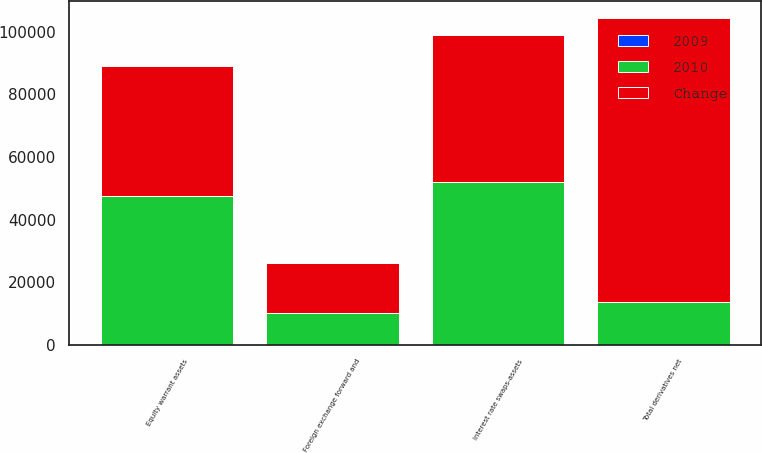Convert chart to OTSL. <chart><loc_0><loc_0><loc_500><loc_500><stacked_bar_chart><ecel><fcel>Equity warrant assets<fcel>Interest rate swaps-assets<fcel>Foreign exchange forward and<fcel>Total derivatives net<nl><fcel>2010<fcel>47565<fcel>52017<fcel>10267<fcel>13609.5<nl><fcel>Change<fcel>41292<fcel>46895<fcel>15870<fcel>90753<nl><fcel>2009<fcel>15.2<fcel>10.9<fcel>35.3<fcel>15.6<nl></chart> 